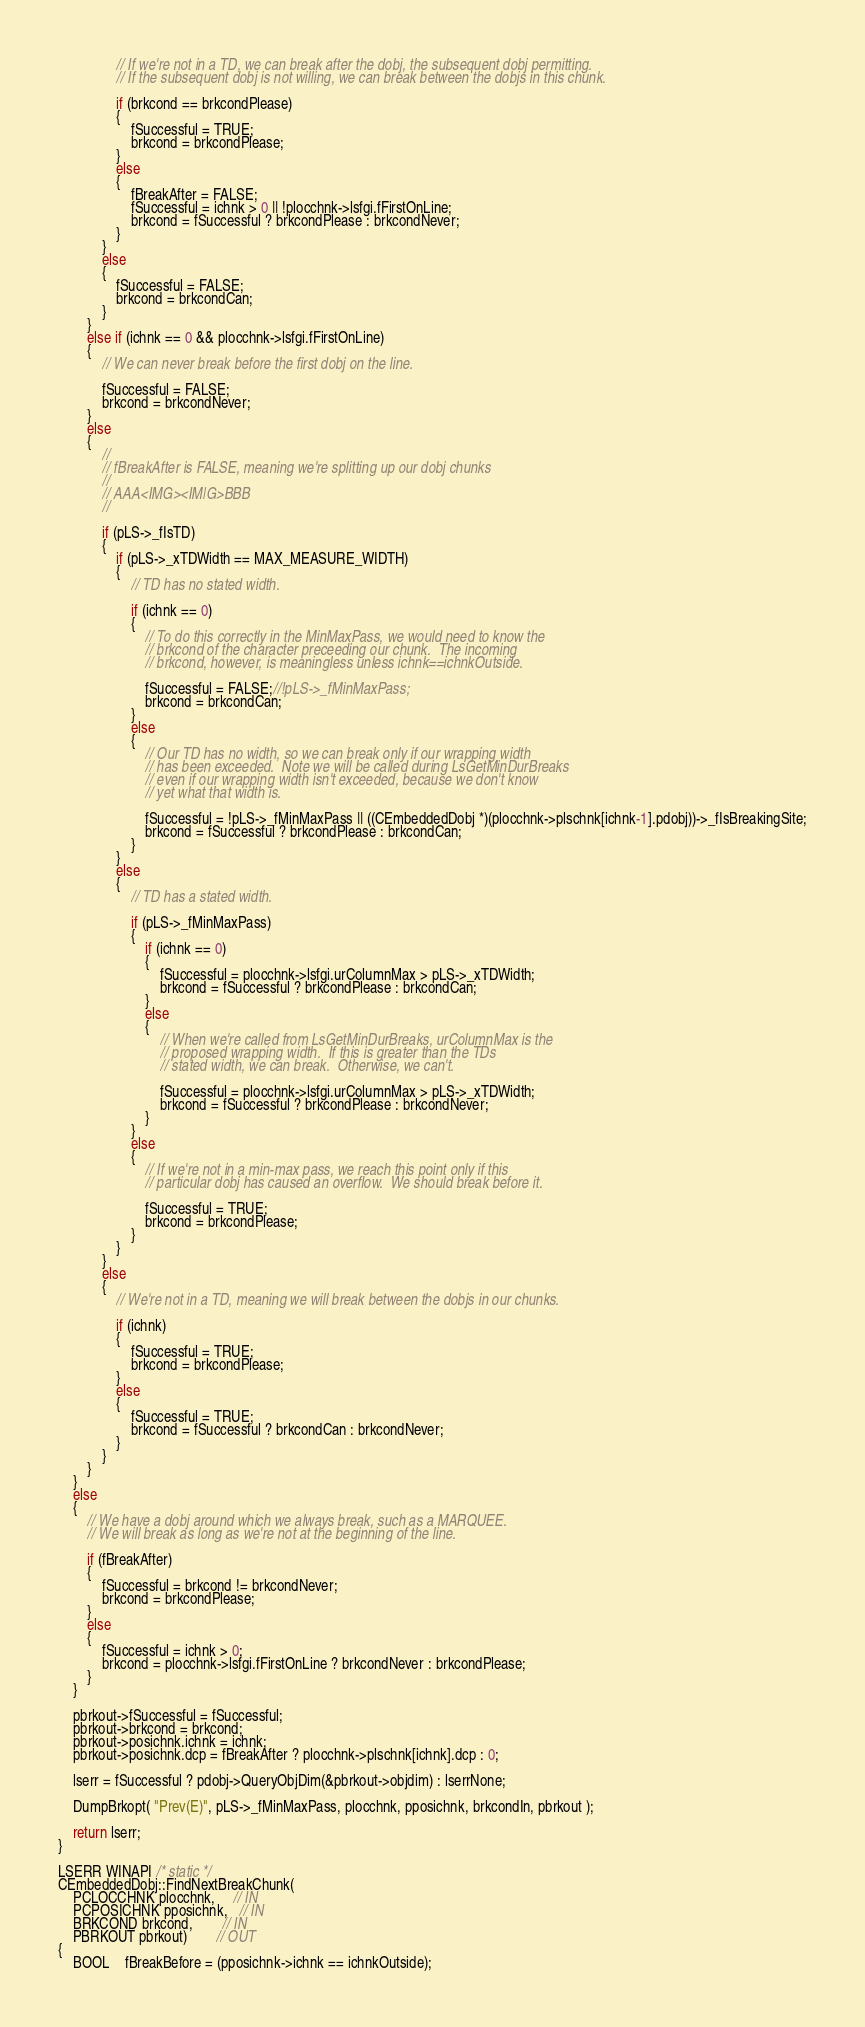<code> <loc_0><loc_0><loc_500><loc_500><_C++_>                // If we're not in a TD, we can break after the dobj, the subsequent dobj permitting.
                // If the subsequent dobj is not willing, we can break between the dobjs in this chunk.

                if (brkcond == brkcondPlease)
                {
                    fSuccessful = TRUE;
                    brkcond = brkcondPlease;
                }
                else
                {
                    fBreakAfter = FALSE;
                    fSuccessful = ichnk > 0 || !plocchnk->lsfgi.fFirstOnLine;
                    brkcond = fSuccessful ? brkcondPlease : brkcondNever;
                }
            }
            else
            {
                fSuccessful = FALSE;
                brkcond = brkcondCan;
            }
        }
        else if (ichnk == 0 && plocchnk->lsfgi.fFirstOnLine)
        {
            // We can never break before the first dobj on the line.

            fSuccessful = FALSE;
            brkcond = brkcondNever;
        }
        else
        {
            //
            // fBreakAfter is FALSE, meaning we're splitting up our dobj chunks
            //
            // AAA<IMG><IM|G>BBB
            //

            if (pLS->_fIsTD)
            {
                if (pLS->_xTDWidth == MAX_MEASURE_WIDTH)
                {
                    // TD has no stated width.
                    
                    if (ichnk == 0)
                    {
                        // To do this correctly in the MinMaxPass, we would need to know the
                        // brkcond of the character preceeding our chunk.  The incoming
                        // brkcond, however, is meaningless unless ichnk==ichnkOutside.
                        
                        fSuccessful = FALSE;//!pLS->_fMinMaxPass;
                        brkcond = brkcondCan;
                    }
                    else
                    {
                        // Our TD has no width, so we can break only if our wrapping width
                        // has been exceeded.  Note we will be called during LsGetMinDurBreaks
                        // even if our wrapping width isn't exceeded, because we don't know
                        // yet what that width is.

                        fSuccessful = !pLS->_fMinMaxPass || ((CEmbeddedDobj *)(plocchnk->plschnk[ichnk-1].pdobj))->_fIsBreakingSite;
                        brkcond = fSuccessful ? brkcondPlease : brkcondCan;
                    }
                }
                else
                {
                    // TD has a stated width.

                    if (pLS->_fMinMaxPass)
                    {
                        if (ichnk == 0)
                        {
                            fSuccessful = plocchnk->lsfgi.urColumnMax > pLS->_xTDWidth;
                            brkcond = fSuccessful ? brkcondPlease : brkcondCan;
                        }
                        else
                        {
                            // When we're called from LsGetMinDurBreaks, urColumnMax is the
                            // proposed wrapping width.  If this is greater than the TDs
                            // stated width, we can break.  Otherwise, we can't.

                            fSuccessful = plocchnk->lsfgi.urColumnMax > pLS->_xTDWidth;
                            brkcond = fSuccessful ? brkcondPlease : brkcondNever;
                        }
                    }
                    else
                    {
                        // If we're not in a min-max pass, we reach this point only if this
                        // particular dobj has caused an overflow.  We should break before it.

                        fSuccessful = TRUE;
                        brkcond = brkcondPlease;
                    }
                }
            }
            else
            {
                // We're not in a TD, meaning we will break between the dobjs in our chunks.

                if (ichnk)
                {
                    fSuccessful = TRUE;
                    brkcond = brkcondPlease;
                }
                else
                {
                    fSuccessful = TRUE;
                    brkcond = fSuccessful ? brkcondCan : brkcondNever;
                }
            }
        }
    }
    else
    {
        // We have a dobj around which we always break, such as a MARQUEE.
        // We will break as long as we're not at the beginning of the line.

        if (fBreakAfter)
        {
            fSuccessful = brkcond != brkcondNever;
            brkcond = brkcondPlease;
        }
        else
        {
            fSuccessful = ichnk > 0;
            brkcond = plocchnk->lsfgi.fFirstOnLine ? brkcondNever : brkcondPlease;
        }
    }

    pbrkout->fSuccessful = fSuccessful;
    pbrkout->brkcond = brkcond;
    pbrkout->posichnk.ichnk = ichnk;
    pbrkout->posichnk.dcp = fBreakAfter ? plocchnk->plschnk[ichnk].dcp : 0;

    lserr = fSuccessful ? pdobj->QueryObjDim(&pbrkout->objdim) : lserrNone;

    DumpBrkopt( "Prev(E)", pLS->_fMinMaxPass, plocchnk, pposichnk, brkcondIn, pbrkout );

    return lserr;
}

LSERR WINAPI /* static */
CEmbeddedDobj::FindNextBreakChunk(
    PCLOCCHNK plocchnk,     // IN
    PCPOSICHNK pposichnk,   // IN
    BRKCOND brkcond,        // IN
    PBRKOUT pbrkout)        // OUT
{
    BOOL    fBreakBefore = (pposichnk->ichnk == ichnkOutside);</code> 